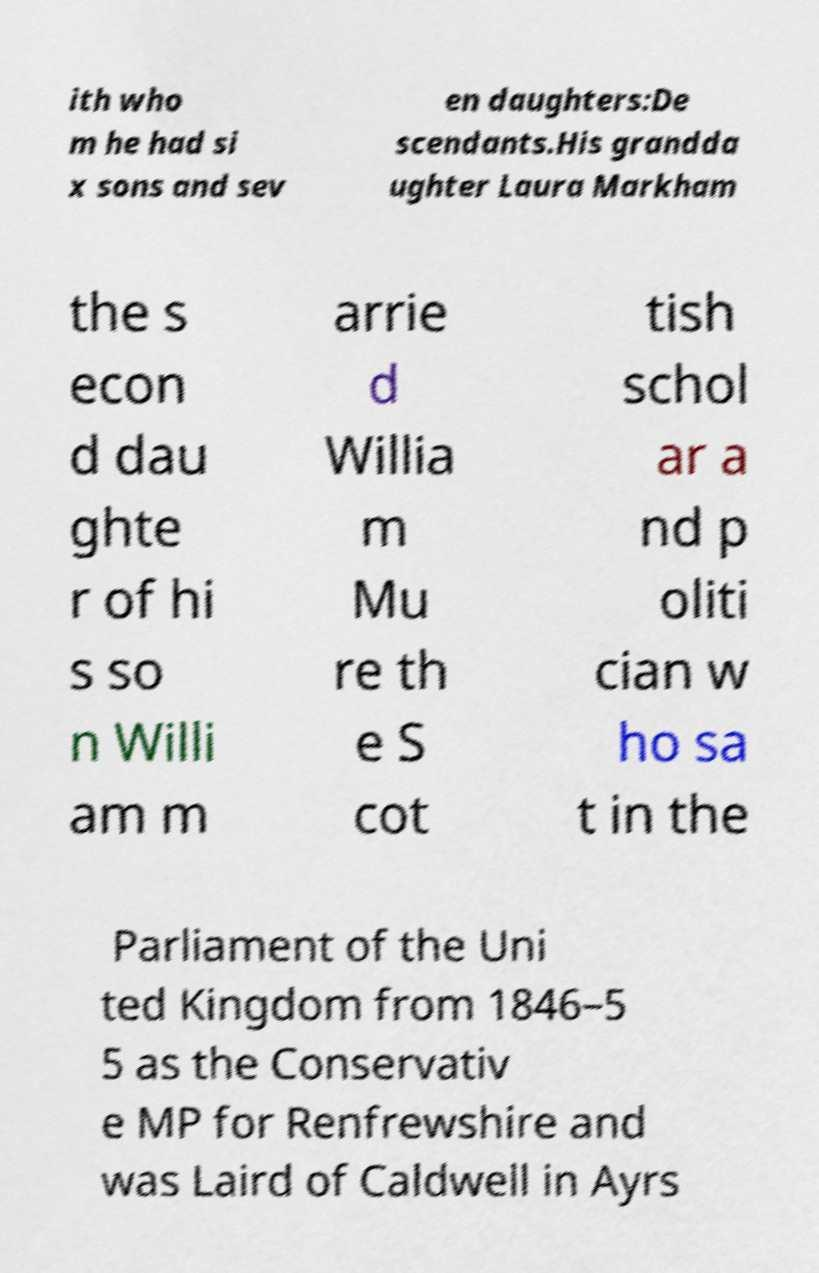Could you extract and type out the text from this image? ith who m he had si x sons and sev en daughters:De scendants.His grandda ughter Laura Markham the s econ d dau ghte r of hi s so n Willi am m arrie d Willia m Mu re th e S cot tish schol ar a nd p oliti cian w ho sa t in the Parliament of the Uni ted Kingdom from 1846–5 5 as the Conservativ e MP for Renfrewshire and was Laird of Caldwell in Ayrs 